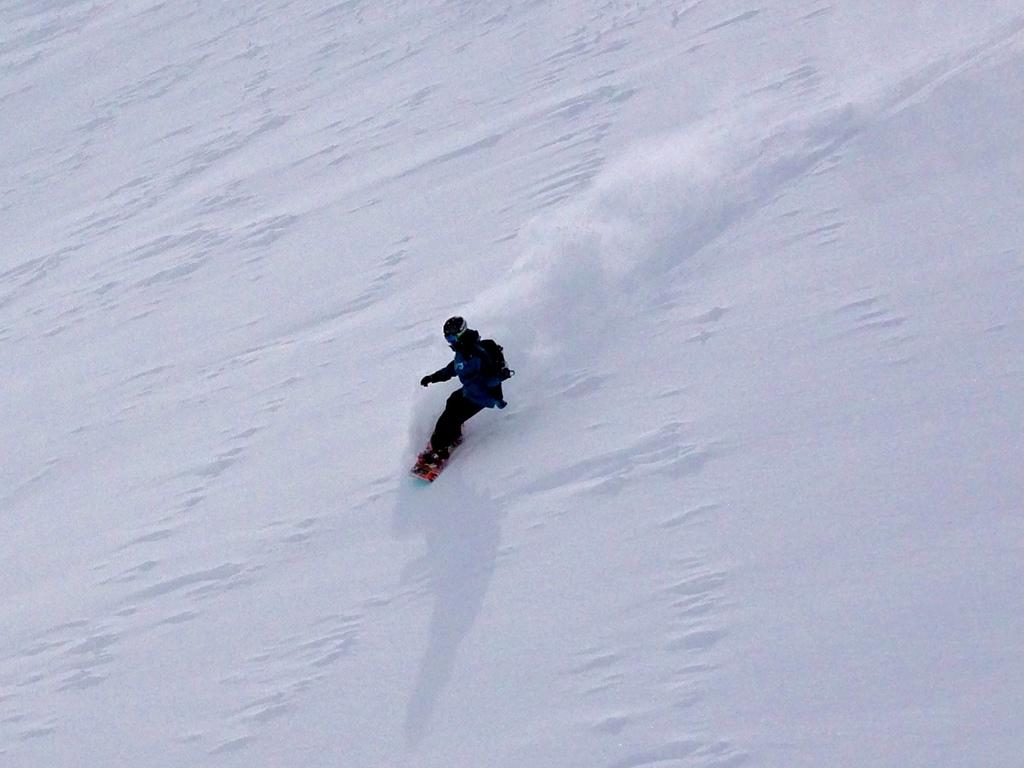What activity is the person in the image engaged in? The person is skiing in the image. What type of clothing is the person wearing for protection? The person is wearing a jacket and a helmet. What is the condition of the ground in the image? The ground is covered with snow. What flavor of ice cream can be seen in the person's hand in the image? There is no ice cream present in the image; the person is skiing on snow-covered ground. 